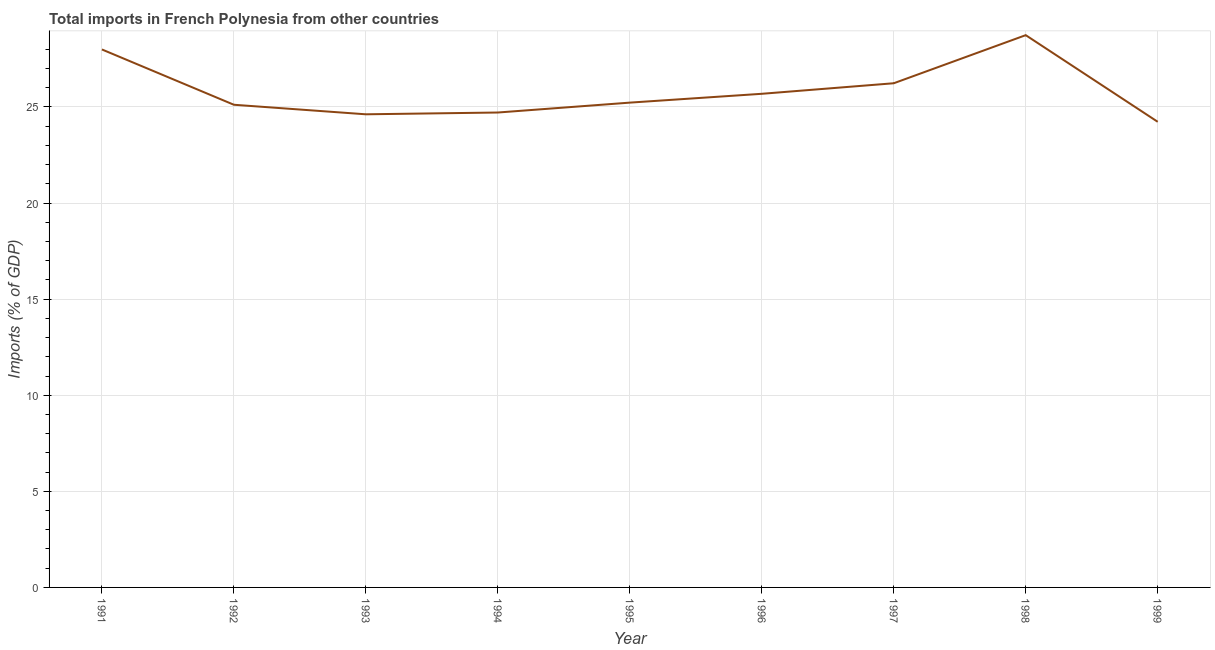What is the total imports in 1999?
Provide a succinct answer. 24.23. Across all years, what is the maximum total imports?
Make the answer very short. 28.74. Across all years, what is the minimum total imports?
Give a very brief answer. 24.23. What is the sum of the total imports?
Keep it short and to the point. 232.56. What is the difference between the total imports in 1991 and 1993?
Keep it short and to the point. 3.37. What is the average total imports per year?
Your answer should be compact. 25.84. What is the median total imports?
Offer a terse response. 25.23. What is the ratio of the total imports in 1996 to that in 1999?
Your answer should be very brief. 1.06. Is the total imports in 1992 less than that in 1993?
Offer a terse response. No. Is the difference between the total imports in 1996 and 1999 greater than the difference between any two years?
Provide a succinct answer. No. What is the difference between the highest and the second highest total imports?
Offer a very short reply. 0.74. What is the difference between the highest and the lowest total imports?
Ensure brevity in your answer.  4.51. Does the total imports monotonically increase over the years?
Give a very brief answer. No. How many lines are there?
Give a very brief answer. 1. How many years are there in the graph?
Your answer should be compact. 9. What is the title of the graph?
Offer a terse response. Total imports in French Polynesia from other countries. What is the label or title of the X-axis?
Offer a terse response. Year. What is the label or title of the Y-axis?
Provide a short and direct response. Imports (% of GDP). What is the Imports (% of GDP) of 1991?
Your answer should be compact. 27.99. What is the Imports (% of GDP) of 1992?
Keep it short and to the point. 25.12. What is the Imports (% of GDP) of 1993?
Your answer should be very brief. 24.62. What is the Imports (% of GDP) in 1994?
Provide a short and direct response. 24.71. What is the Imports (% of GDP) in 1995?
Offer a terse response. 25.23. What is the Imports (% of GDP) of 1996?
Make the answer very short. 25.69. What is the Imports (% of GDP) of 1997?
Give a very brief answer. 26.24. What is the Imports (% of GDP) of 1998?
Provide a short and direct response. 28.74. What is the Imports (% of GDP) of 1999?
Your answer should be very brief. 24.23. What is the difference between the Imports (% of GDP) in 1991 and 1992?
Your answer should be compact. 2.88. What is the difference between the Imports (% of GDP) in 1991 and 1993?
Offer a terse response. 3.37. What is the difference between the Imports (% of GDP) in 1991 and 1994?
Offer a terse response. 3.28. What is the difference between the Imports (% of GDP) in 1991 and 1995?
Keep it short and to the point. 2.77. What is the difference between the Imports (% of GDP) in 1991 and 1996?
Offer a very short reply. 2.31. What is the difference between the Imports (% of GDP) in 1991 and 1997?
Make the answer very short. 1.76. What is the difference between the Imports (% of GDP) in 1991 and 1998?
Your response must be concise. -0.74. What is the difference between the Imports (% of GDP) in 1991 and 1999?
Keep it short and to the point. 3.76. What is the difference between the Imports (% of GDP) in 1992 and 1993?
Provide a short and direct response. 0.5. What is the difference between the Imports (% of GDP) in 1992 and 1994?
Provide a succinct answer. 0.4. What is the difference between the Imports (% of GDP) in 1992 and 1995?
Your response must be concise. -0.11. What is the difference between the Imports (% of GDP) in 1992 and 1996?
Ensure brevity in your answer.  -0.57. What is the difference between the Imports (% of GDP) in 1992 and 1997?
Provide a short and direct response. -1.12. What is the difference between the Imports (% of GDP) in 1992 and 1998?
Offer a terse response. -3.62. What is the difference between the Imports (% of GDP) in 1992 and 1999?
Your answer should be compact. 0.89. What is the difference between the Imports (% of GDP) in 1993 and 1994?
Keep it short and to the point. -0.09. What is the difference between the Imports (% of GDP) in 1993 and 1995?
Provide a succinct answer. -0.61. What is the difference between the Imports (% of GDP) in 1993 and 1996?
Keep it short and to the point. -1.07. What is the difference between the Imports (% of GDP) in 1993 and 1997?
Provide a succinct answer. -1.62. What is the difference between the Imports (% of GDP) in 1993 and 1998?
Ensure brevity in your answer.  -4.12. What is the difference between the Imports (% of GDP) in 1993 and 1999?
Your answer should be very brief. 0.39. What is the difference between the Imports (% of GDP) in 1994 and 1995?
Make the answer very short. -0.51. What is the difference between the Imports (% of GDP) in 1994 and 1996?
Ensure brevity in your answer.  -0.97. What is the difference between the Imports (% of GDP) in 1994 and 1997?
Provide a short and direct response. -1.52. What is the difference between the Imports (% of GDP) in 1994 and 1998?
Make the answer very short. -4.03. What is the difference between the Imports (% of GDP) in 1994 and 1999?
Make the answer very short. 0.48. What is the difference between the Imports (% of GDP) in 1995 and 1996?
Your answer should be very brief. -0.46. What is the difference between the Imports (% of GDP) in 1995 and 1997?
Your answer should be very brief. -1.01. What is the difference between the Imports (% of GDP) in 1995 and 1998?
Offer a terse response. -3.51. What is the difference between the Imports (% of GDP) in 1995 and 1999?
Ensure brevity in your answer.  1. What is the difference between the Imports (% of GDP) in 1996 and 1997?
Provide a short and direct response. -0.55. What is the difference between the Imports (% of GDP) in 1996 and 1998?
Your answer should be very brief. -3.05. What is the difference between the Imports (% of GDP) in 1996 and 1999?
Your answer should be compact. 1.46. What is the difference between the Imports (% of GDP) in 1997 and 1998?
Provide a succinct answer. -2.5. What is the difference between the Imports (% of GDP) in 1997 and 1999?
Make the answer very short. 2.01. What is the difference between the Imports (% of GDP) in 1998 and 1999?
Provide a succinct answer. 4.51. What is the ratio of the Imports (% of GDP) in 1991 to that in 1992?
Make the answer very short. 1.11. What is the ratio of the Imports (% of GDP) in 1991 to that in 1993?
Your answer should be very brief. 1.14. What is the ratio of the Imports (% of GDP) in 1991 to that in 1994?
Give a very brief answer. 1.13. What is the ratio of the Imports (% of GDP) in 1991 to that in 1995?
Provide a short and direct response. 1.11. What is the ratio of the Imports (% of GDP) in 1991 to that in 1996?
Offer a terse response. 1.09. What is the ratio of the Imports (% of GDP) in 1991 to that in 1997?
Offer a terse response. 1.07. What is the ratio of the Imports (% of GDP) in 1991 to that in 1999?
Your response must be concise. 1.16. What is the ratio of the Imports (% of GDP) in 1992 to that in 1993?
Your answer should be very brief. 1.02. What is the ratio of the Imports (% of GDP) in 1992 to that in 1994?
Your response must be concise. 1.02. What is the ratio of the Imports (% of GDP) in 1992 to that in 1995?
Provide a short and direct response. 1. What is the ratio of the Imports (% of GDP) in 1992 to that in 1996?
Provide a short and direct response. 0.98. What is the ratio of the Imports (% of GDP) in 1992 to that in 1998?
Your response must be concise. 0.87. What is the ratio of the Imports (% of GDP) in 1993 to that in 1994?
Make the answer very short. 1. What is the ratio of the Imports (% of GDP) in 1993 to that in 1995?
Make the answer very short. 0.98. What is the ratio of the Imports (% of GDP) in 1993 to that in 1996?
Ensure brevity in your answer.  0.96. What is the ratio of the Imports (% of GDP) in 1993 to that in 1997?
Give a very brief answer. 0.94. What is the ratio of the Imports (% of GDP) in 1993 to that in 1998?
Keep it short and to the point. 0.86. What is the ratio of the Imports (% of GDP) in 1994 to that in 1996?
Offer a terse response. 0.96. What is the ratio of the Imports (% of GDP) in 1994 to that in 1997?
Offer a terse response. 0.94. What is the ratio of the Imports (% of GDP) in 1994 to that in 1998?
Keep it short and to the point. 0.86. What is the ratio of the Imports (% of GDP) in 1994 to that in 1999?
Ensure brevity in your answer.  1.02. What is the ratio of the Imports (% of GDP) in 1995 to that in 1996?
Offer a very short reply. 0.98. What is the ratio of the Imports (% of GDP) in 1995 to that in 1998?
Your response must be concise. 0.88. What is the ratio of the Imports (% of GDP) in 1995 to that in 1999?
Offer a very short reply. 1.04. What is the ratio of the Imports (% of GDP) in 1996 to that in 1998?
Offer a terse response. 0.89. What is the ratio of the Imports (% of GDP) in 1996 to that in 1999?
Make the answer very short. 1.06. What is the ratio of the Imports (% of GDP) in 1997 to that in 1998?
Offer a terse response. 0.91. What is the ratio of the Imports (% of GDP) in 1997 to that in 1999?
Make the answer very short. 1.08. What is the ratio of the Imports (% of GDP) in 1998 to that in 1999?
Give a very brief answer. 1.19. 